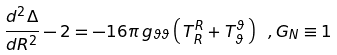<formula> <loc_0><loc_0><loc_500><loc_500>\frac { d ^ { 2 } \Delta } { d R ^ { 2 } } - 2 = - 1 6 \pi \, g _ { \vartheta \vartheta } \left ( \, T ^ { R } _ { R } + T ^ { \vartheta } _ { \vartheta } \, \right ) \ , G _ { N } \equiv 1</formula> 